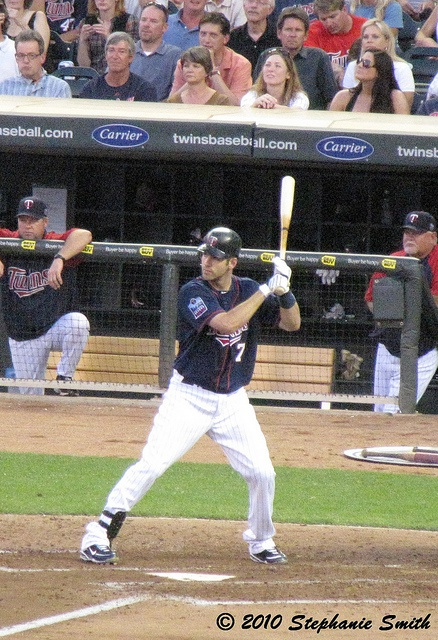Describe the objects in this image and their specific colors. I can see people in gray, white, and black tones, people in gray, black, darkgray, and lavender tones, bench in gray and tan tones, people in gray, black, lavender, and brown tones, and people in gray, black, lightgray, and darkgray tones in this image. 